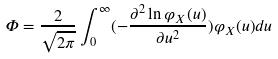<formula> <loc_0><loc_0><loc_500><loc_500>\Phi = \frac { 2 } { \sqrt { 2 \pi } } \int _ { 0 } ^ { \infty } ( - \frac { \partial ^ { 2 } \ln \varphi _ { X } ( u ) } { \partial u ^ { 2 } } ) \varphi _ { X } ( u ) d u</formula> 